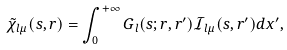<formula> <loc_0><loc_0><loc_500><loc_500>\tilde { \chi } _ { l \mu } ( s , r ) = \int _ { 0 } ^ { + \infty } { G _ { l } ( s ; r , r ^ { \prime } ) \mathcal { I } _ { \, l \mu } ( s , r ^ { \prime } ) d x ^ { \prime } } ,</formula> 